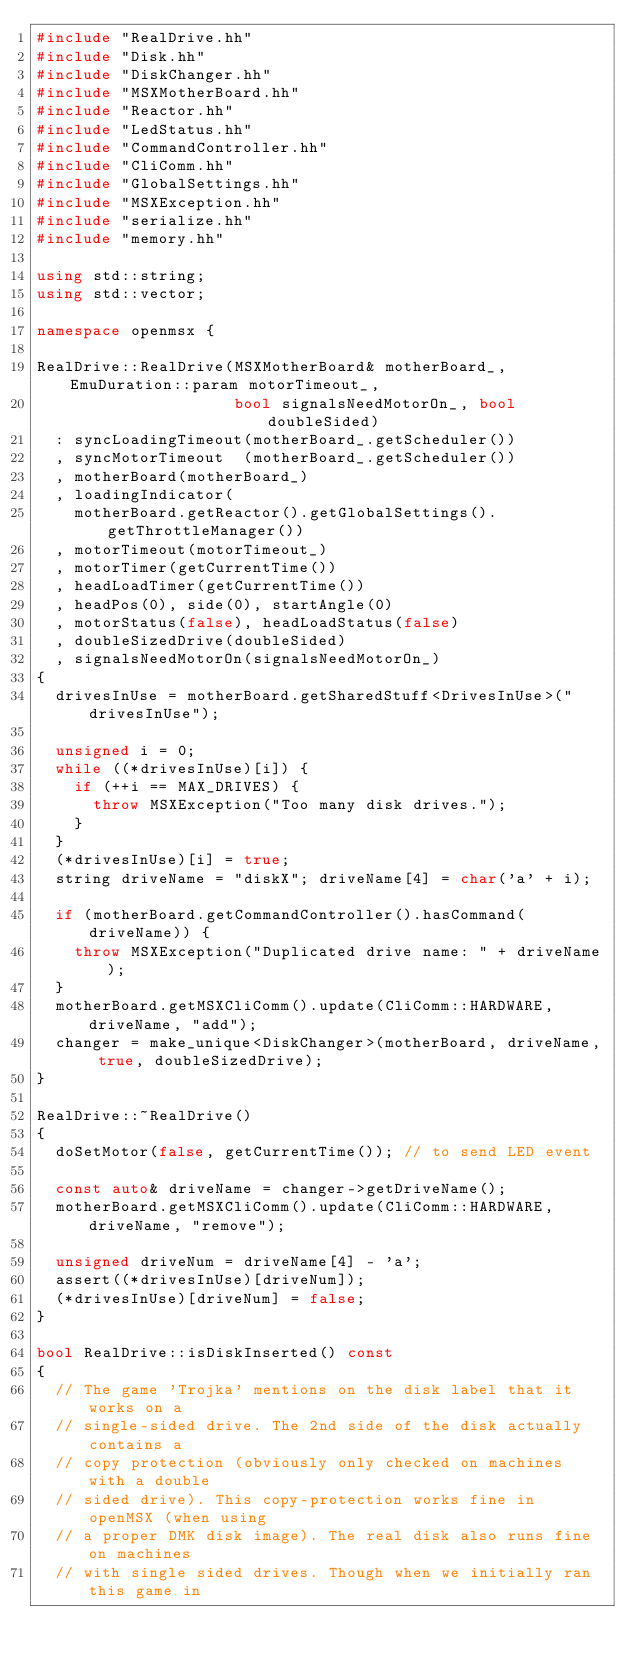Convert code to text. <code><loc_0><loc_0><loc_500><loc_500><_C++_>#include "RealDrive.hh"
#include "Disk.hh"
#include "DiskChanger.hh"
#include "MSXMotherBoard.hh"
#include "Reactor.hh"
#include "LedStatus.hh"
#include "CommandController.hh"
#include "CliComm.hh"
#include "GlobalSettings.hh"
#include "MSXException.hh"
#include "serialize.hh"
#include "memory.hh"

using std::string;
using std::vector;

namespace openmsx {

RealDrive::RealDrive(MSXMotherBoard& motherBoard_, EmuDuration::param motorTimeout_,
                     bool signalsNeedMotorOn_, bool doubleSided)
	: syncLoadingTimeout(motherBoard_.getScheduler())
	, syncMotorTimeout  (motherBoard_.getScheduler())
	, motherBoard(motherBoard_)
	, loadingIndicator(
		motherBoard.getReactor().getGlobalSettings().getThrottleManager())
	, motorTimeout(motorTimeout_)
	, motorTimer(getCurrentTime())
	, headLoadTimer(getCurrentTime())
	, headPos(0), side(0), startAngle(0)
	, motorStatus(false), headLoadStatus(false)
	, doubleSizedDrive(doubleSided)
	, signalsNeedMotorOn(signalsNeedMotorOn_)
{
	drivesInUse = motherBoard.getSharedStuff<DrivesInUse>("drivesInUse");

	unsigned i = 0;
	while ((*drivesInUse)[i]) {
		if (++i == MAX_DRIVES) {
			throw MSXException("Too many disk drives.");
		}
	}
	(*drivesInUse)[i] = true;
	string driveName = "diskX"; driveName[4] = char('a' + i);

	if (motherBoard.getCommandController().hasCommand(driveName)) {
		throw MSXException("Duplicated drive name: " + driveName);
	}
	motherBoard.getMSXCliComm().update(CliComm::HARDWARE, driveName, "add");
	changer = make_unique<DiskChanger>(motherBoard, driveName, true, doubleSizedDrive);
}

RealDrive::~RealDrive()
{
	doSetMotor(false, getCurrentTime()); // to send LED event

	const auto& driveName = changer->getDriveName();
	motherBoard.getMSXCliComm().update(CliComm::HARDWARE, driveName, "remove");

	unsigned driveNum = driveName[4] - 'a';
	assert((*drivesInUse)[driveNum]);
	(*drivesInUse)[driveNum] = false;
}

bool RealDrive::isDiskInserted() const
{
	// The game 'Trojka' mentions on the disk label that it works on a
	// single-sided drive. The 2nd side of the disk actually contains a
	// copy protection (obviously only checked on machines with a double
	// sided drive). This copy-protection works fine in openMSX (when using
	// a proper DMK disk image). The real disk also runs fine on machines
	// with single sided drives. Though when we initially ran this game in</code> 